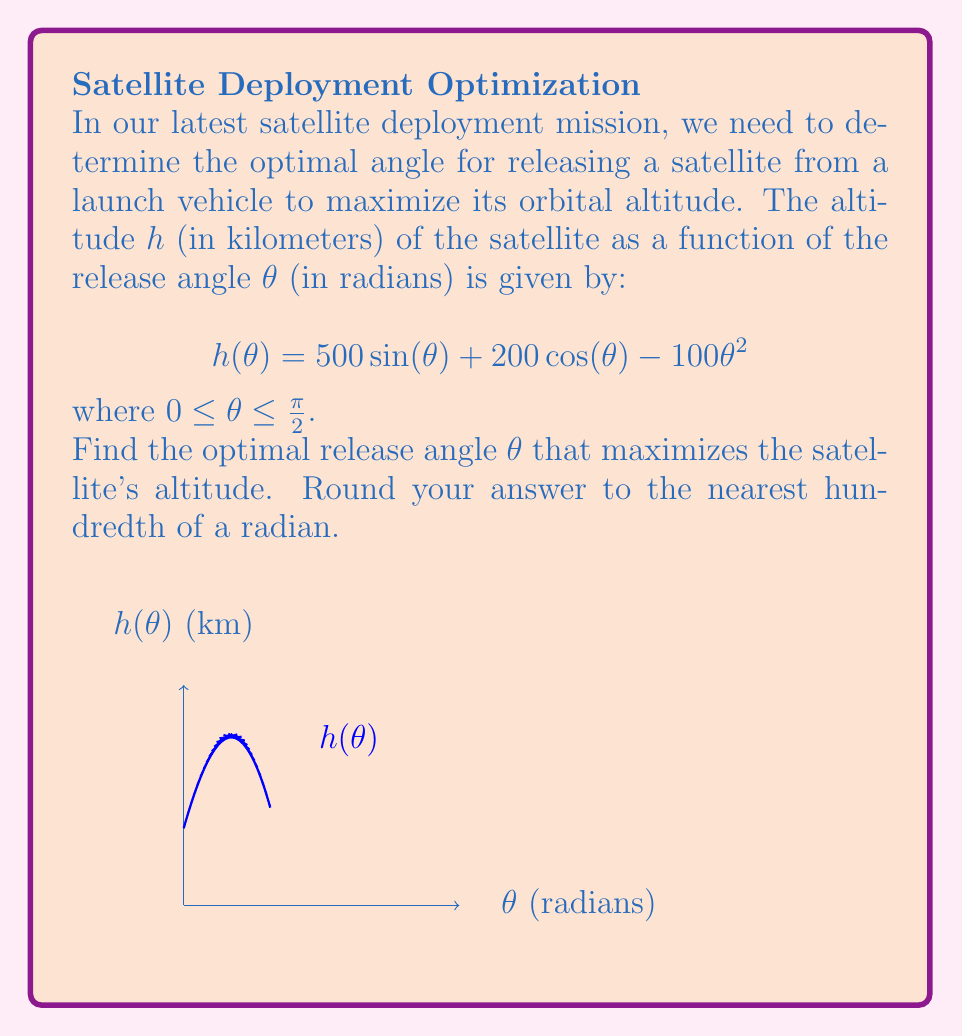Could you help me with this problem? To find the optimal angle, we need to determine where the derivative of $h(\theta)$ equals zero:

1) First, let's find the derivative of $h(\theta)$:
   $$h'(\theta) = 500 \cos(\theta) - 200 \sin(\theta) - 200\theta$$

2) Set $h'(\theta) = 0$ and solve for $\theta$:
   $$500 \cos(\theta) - 200 \sin(\theta) - 200\theta = 0$$

3) This equation cannot be solved algebraically. We need to use numerical methods such as Newton's method or a graphing calculator to find the solution.

4) Using a numerical solver, we find that the equation is satisfied when $\theta \approx 0.7854$ radians.

5) To confirm this is a maximum, we can check the second derivative:
   $$h''(\theta) = -500 \sin(\theta) - 200 \cos(\theta) - 200$$
   
   At $\theta = 0.7854$, $h''(\theta) < 0$, confirming it's a maximum.

6) Rounding to the nearest hundredth:
   $\theta \approx 0.79$ radians

Therefore, the optimal release angle to maximize the satellite's altitude is approximately 0.79 radians.
Answer: 0.79 radians 